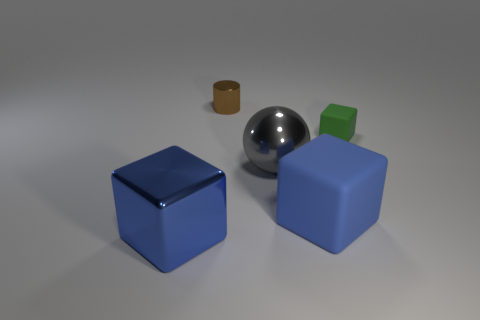Add 3 small purple shiny cylinders. How many objects exist? 8 Subtract all spheres. How many objects are left? 4 Subtract 1 green blocks. How many objects are left? 4 Subtract all green rubber cubes. Subtract all blue objects. How many objects are left? 2 Add 2 large blue objects. How many large blue objects are left? 4 Add 1 big brown rubber cubes. How many big brown rubber cubes exist? 1 